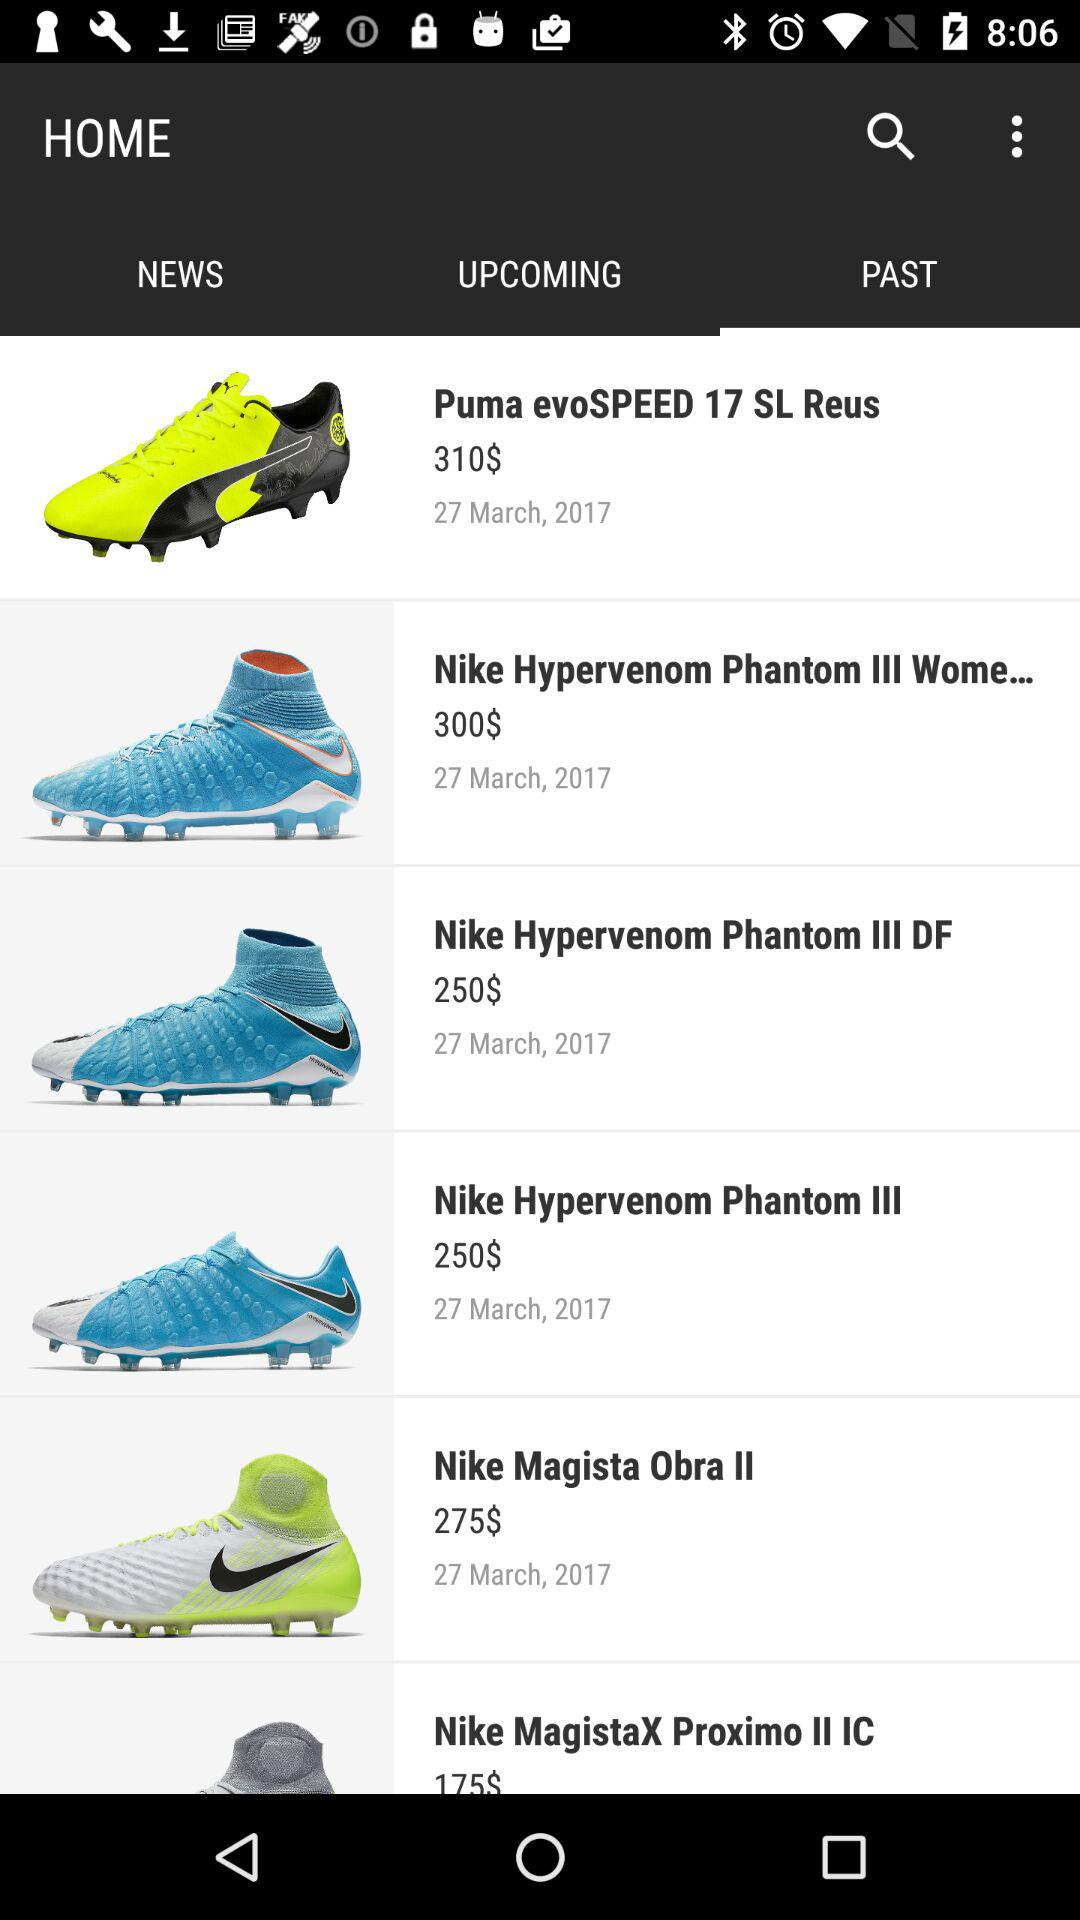How much are "Puma evoSPEED" shoes priced? The price is $310. 